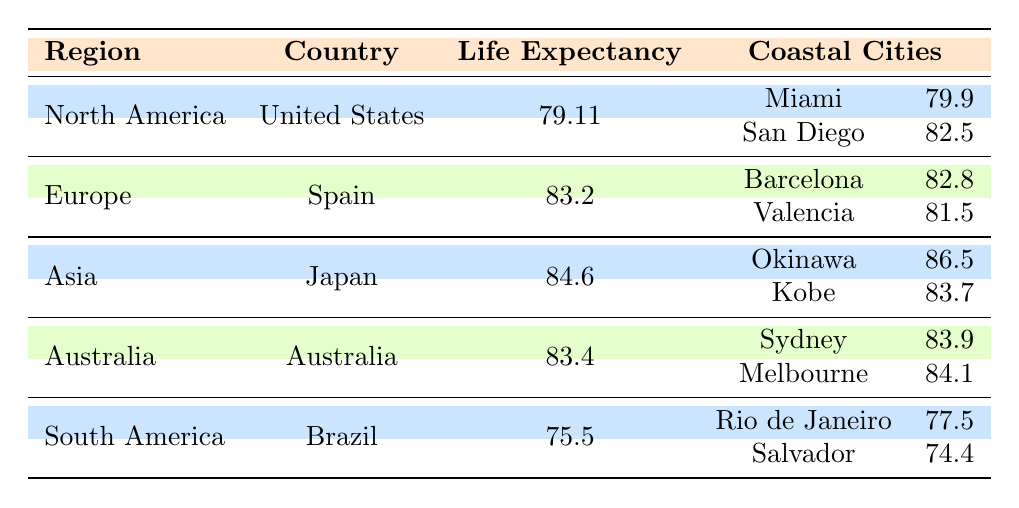What is the life expectancy in North America? The table lists North America under the region of the United States, showing a life expectancy of 79.11 years.
Answer: 79.11 Which coastal city in the United States has the highest life expectancy? The table shows two cities: Miami with 79.9 and San Diego with 82.5. Since 82.5 is greater than 79.9, San Diego has the highest life expectancy.
Answer: San Diego Is the life expectancy in Brazil higher or lower than the global average from the table? The life expectancy in Brazil is 75.5, which is lower compared to countries listed in the table. The highest life expectancy is from Japan at 84.6. Thus, Brazil's life expectancy is lower.
Answer: Lower What is the average life expectancy of coastal cities in Japan? The cities listed for Japan are Okinawa with 86.5 and Kobe with 83.7. To find the average, add these two values: 86.5 + 83.7 = 170.2, and then divide by 2, yielding an average of 85.1.
Answer: 85.1 Which region has the highest life expectancy overall? From the table, Japan in Asia has the highest life expectancy at 84.6, which is greater than other regions including Europe (83.2), Australia (83.4), North America (79.11), and South America (75.5).
Answer: Asia Are there more coastal cities listed under North America or Europe? North America has two cities (Miami and San Diego) listed, and Europe also has two cities (Barcelona and Valencia) listed. Therefore, they have the same number of coastal cities.
Answer: No What is the difference in life expectancy between the coastal cities of Brazil? The coastal cities in Brazil are Rio de Janeiro with a life expectancy of 77.5 and Salvador with 74.4. The difference is 77.5 - 74.4 = 3.1.
Answer: 3.1 Which coastal city has the highest life expectancy across all regions in the table? The table shows Okinawa in Japan with a life expectancy of 86.5, which is the highest compared to all other coastal cities listed.
Answer: Okinawa 